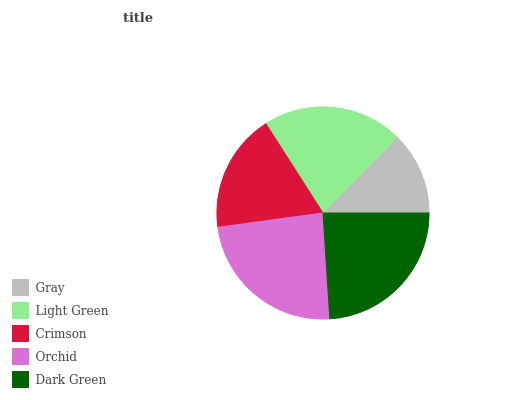Is Gray the minimum?
Answer yes or no. Yes. Is Dark Green the maximum?
Answer yes or no. Yes. Is Light Green the minimum?
Answer yes or no. No. Is Light Green the maximum?
Answer yes or no. No. Is Light Green greater than Gray?
Answer yes or no. Yes. Is Gray less than Light Green?
Answer yes or no. Yes. Is Gray greater than Light Green?
Answer yes or no. No. Is Light Green less than Gray?
Answer yes or no. No. Is Light Green the high median?
Answer yes or no. Yes. Is Light Green the low median?
Answer yes or no. Yes. Is Orchid the high median?
Answer yes or no. No. Is Dark Green the low median?
Answer yes or no. No. 